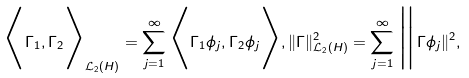Convert formula to latex. <formula><loc_0><loc_0><loc_500><loc_500>\Big < \Gamma _ { 1 } , \Gamma _ { 2 } \Big > _ { \mathcal { L } _ { 2 } ( H ) } = \sum _ { j = 1 } ^ { \infty } \Big < \Gamma _ { 1 } \phi _ { j } , \Gamma _ { 2 } \phi _ { j } \Big > , \| \Gamma \| ^ { 2 } _ { \mathcal { L } _ { 2 } ( H ) } = \sum _ { j = 1 } ^ { \infty } \Big \| \Gamma \phi _ { j } \| ^ { 2 } ,</formula> 